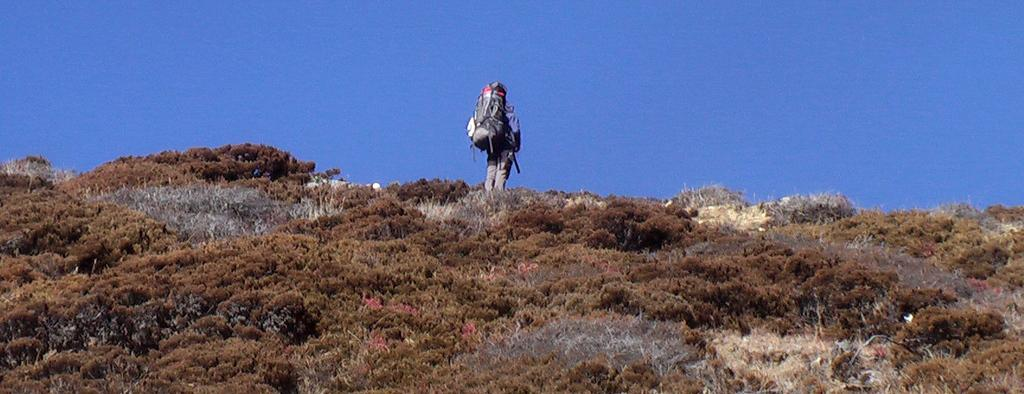Who or what is present in the image? There is a person in the image. What is the person wearing? The person is wearing a bag. What type of natural environment can be seen in the image? There are trees in the image. What is visible in the background of the image? The sky is visible in the background of the image. How many cakes can be seen in the image? There are no cakes present in the image. What color are the person's eyes in the image? The provided facts do not mention the person's eyes, so we cannot determine their color from the image. 